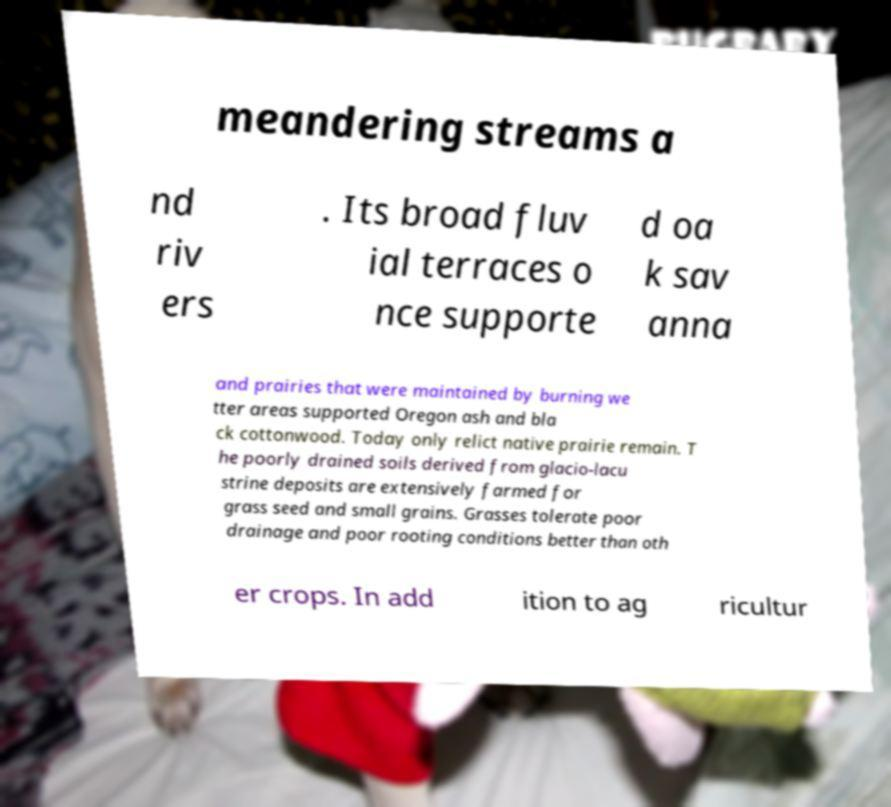Could you assist in decoding the text presented in this image and type it out clearly? meandering streams a nd riv ers . Its broad fluv ial terraces o nce supporte d oa k sav anna and prairies that were maintained by burning we tter areas supported Oregon ash and bla ck cottonwood. Today only relict native prairie remain. T he poorly drained soils derived from glacio-lacu strine deposits are extensively farmed for grass seed and small grains. Grasses tolerate poor drainage and poor rooting conditions better than oth er crops. In add ition to ag ricultur 